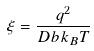Convert formula to latex. <formula><loc_0><loc_0><loc_500><loc_500>\xi = \frac { q ^ { 2 } } { D b k _ { B } T }</formula> 